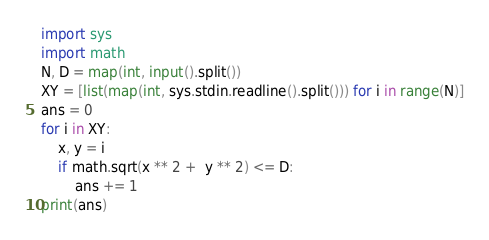Convert code to text. <code><loc_0><loc_0><loc_500><loc_500><_Python_>import sys
import math
N, D = map(int, input().split())
XY = [list(map(int, sys.stdin.readline().split())) for i in range(N)]
ans = 0
for i in XY:
    x, y = i
    if math.sqrt(x ** 2 +  y ** 2) <= D:
        ans += 1
print(ans)</code> 